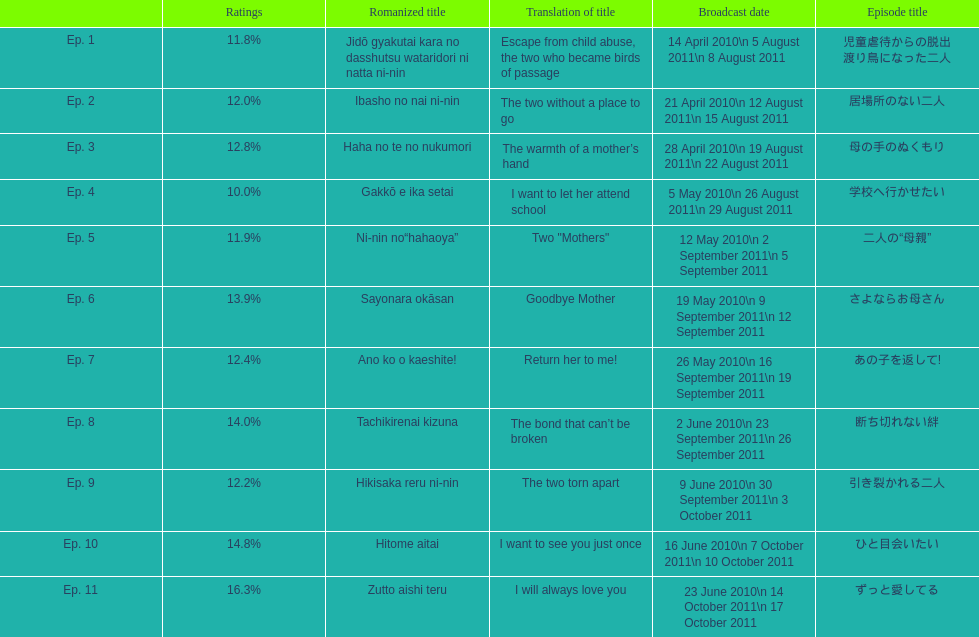What was the top rated episode of this show? ずっと愛してる. 